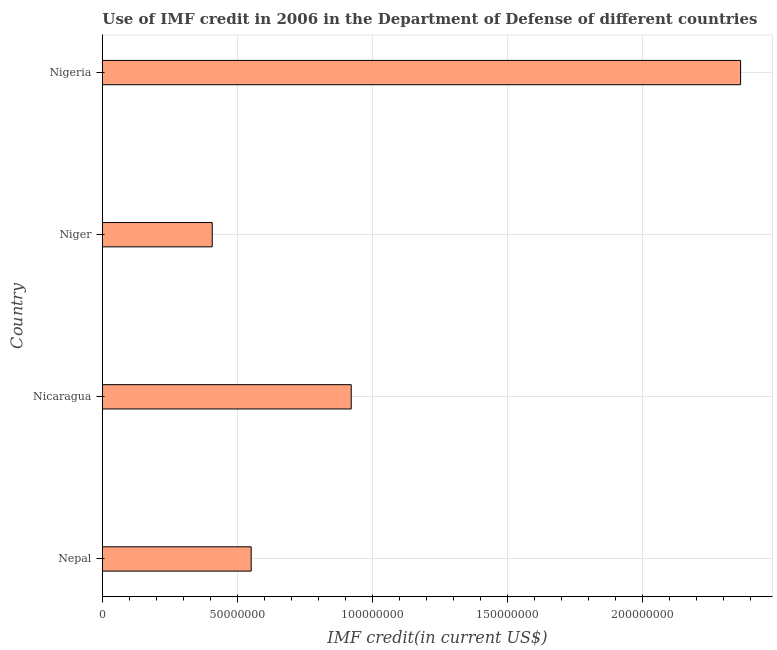What is the title of the graph?
Offer a very short reply. Use of IMF credit in 2006 in the Department of Defense of different countries. What is the label or title of the X-axis?
Offer a very short reply. IMF credit(in current US$). What is the use of imf credit in dod in Nicaragua?
Provide a succinct answer. 9.22e+07. Across all countries, what is the maximum use of imf credit in dod?
Offer a terse response. 2.36e+08. Across all countries, what is the minimum use of imf credit in dod?
Give a very brief answer. 4.07e+07. In which country was the use of imf credit in dod maximum?
Your response must be concise. Nigeria. In which country was the use of imf credit in dod minimum?
Your answer should be compact. Niger. What is the sum of the use of imf credit in dod?
Ensure brevity in your answer.  4.24e+08. What is the difference between the use of imf credit in dod in Nepal and Nicaragua?
Provide a short and direct response. -3.71e+07. What is the average use of imf credit in dod per country?
Your answer should be compact. 1.06e+08. What is the median use of imf credit in dod?
Ensure brevity in your answer.  7.36e+07. In how many countries, is the use of imf credit in dod greater than 100000000 US$?
Your answer should be compact. 1. What is the ratio of the use of imf credit in dod in Niger to that in Nigeria?
Give a very brief answer. 0.17. Is the use of imf credit in dod in Nepal less than that in Nicaragua?
Your answer should be compact. Yes. What is the difference between the highest and the second highest use of imf credit in dod?
Your answer should be compact. 1.44e+08. What is the difference between the highest and the lowest use of imf credit in dod?
Provide a succinct answer. 1.96e+08. How many bars are there?
Your answer should be compact. 4. What is the IMF credit(in current US$) in Nepal?
Provide a succinct answer. 5.51e+07. What is the IMF credit(in current US$) of Nicaragua?
Your response must be concise. 9.22e+07. What is the IMF credit(in current US$) of Niger?
Make the answer very short. 4.07e+07. What is the IMF credit(in current US$) of Nigeria?
Provide a succinct answer. 2.36e+08. What is the difference between the IMF credit(in current US$) in Nepal and Nicaragua?
Provide a short and direct response. -3.71e+07. What is the difference between the IMF credit(in current US$) in Nepal and Niger?
Your answer should be compact. 1.44e+07. What is the difference between the IMF credit(in current US$) in Nepal and Nigeria?
Give a very brief answer. -1.81e+08. What is the difference between the IMF credit(in current US$) in Nicaragua and Niger?
Give a very brief answer. 5.15e+07. What is the difference between the IMF credit(in current US$) in Nicaragua and Nigeria?
Make the answer very short. -1.44e+08. What is the difference between the IMF credit(in current US$) in Niger and Nigeria?
Make the answer very short. -1.96e+08. What is the ratio of the IMF credit(in current US$) in Nepal to that in Nicaragua?
Give a very brief answer. 0.6. What is the ratio of the IMF credit(in current US$) in Nepal to that in Niger?
Offer a terse response. 1.35. What is the ratio of the IMF credit(in current US$) in Nepal to that in Nigeria?
Provide a short and direct response. 0.23. What is the ratio of the IMF credit(in current US$) in Nicaragua to that in Niger?
Offer a very short reply. 2.27. What is the ratio of the IMF credit(in current US$) in Nicaragua to that in Nigeria?
Provide a succinct answer. 0.39. What is the ratio of the IMF credit(in current US$) in Niger to that in Nigeria?
Provide a succinct answer. 0.17. 